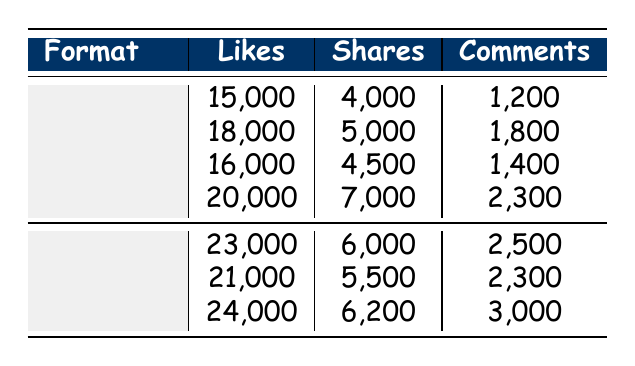What is the total number of likes for Skits? The likes for each Skit are 15,000, 18,000, 16,000, and 20,000. Adding these gives: 15,000 + 18,000 + 16,000 + 20,000 = 69,000.
Answer: 69,000 Which Interview format received the most likes? The likes for the Interview formats are 23,000, 21,000, and 24,000. The highest value is 24,000 from Returning Guest Interviews with Will Ferrell.
Answer: 24,000 Did Skits overall receive more shares than Interviews? The total shares for Skits are 4,000 + 5,000 + 4,500 + 7,000 = 20,500, and for Interviews, they are 6,000 + 5,500 + 6,200 = 17,700. Since 20,500 is greater than 17,700, the answer is yes.
Answer: Yes What is the average number of comments for the Interview formats? The total comments for Interviews are 2,500 + 2,300 + 3,000 = 7,800. There are 3 Interview formats, so the average is 7,800 / 3 = 2,600.
Answer: 2,600 Which format (Skit or Interview) had the highest individual engagement (likes, shares, comments combined) in one segment? Calculate the total engagement for each segment. For Skits: 15,000 + 4,000 + 1,200 = 20,200, 18,000 + 5,000 + 1,800 = 24,800, 16,000 + 4,500 + 1,400 = 21,900, and 20,000 + 7,000 + 2,300 = 29,300. For Interviews: 23,000 + 6,000 + 2,500 = 31,500, 21,000 + 5,500 + 2,300 = 28,800, 24,000 + 6,200 + 3,000 = 33,200. The highest is for Interviews, specifically the segment with 24,000 likes, 6,200 shares, and 3,000 comments, totaling 33,200.
Answer: Interview What is the total number of comments across all formats? To find the total comments, add the comments across all segments. For Skits: 1,200 + 1,800 + 1,400 + 2,300 = 6,700. For Interviews: 2,500 + 2,300 + 3,000 = 7,800. The grand total is 6,700 + 7,800 = 14,500.
Answer: 14,500 